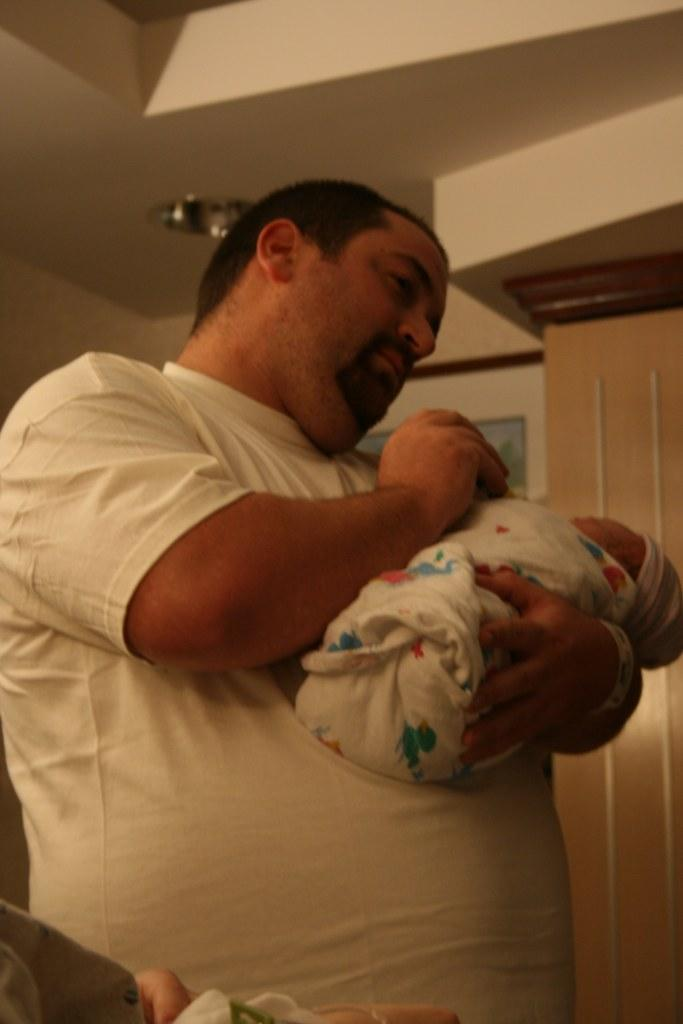Who is the main subject in the image? There is a man in the image. What is the man doing in the image? The man is holding a baby. What can be seen in the background of the image? There is a wall, a pillar, and a light in the background of the image. What type of bells can be heard ringing in the background of the image? There are no bells present in the image, and therefore no sound can be heard. 